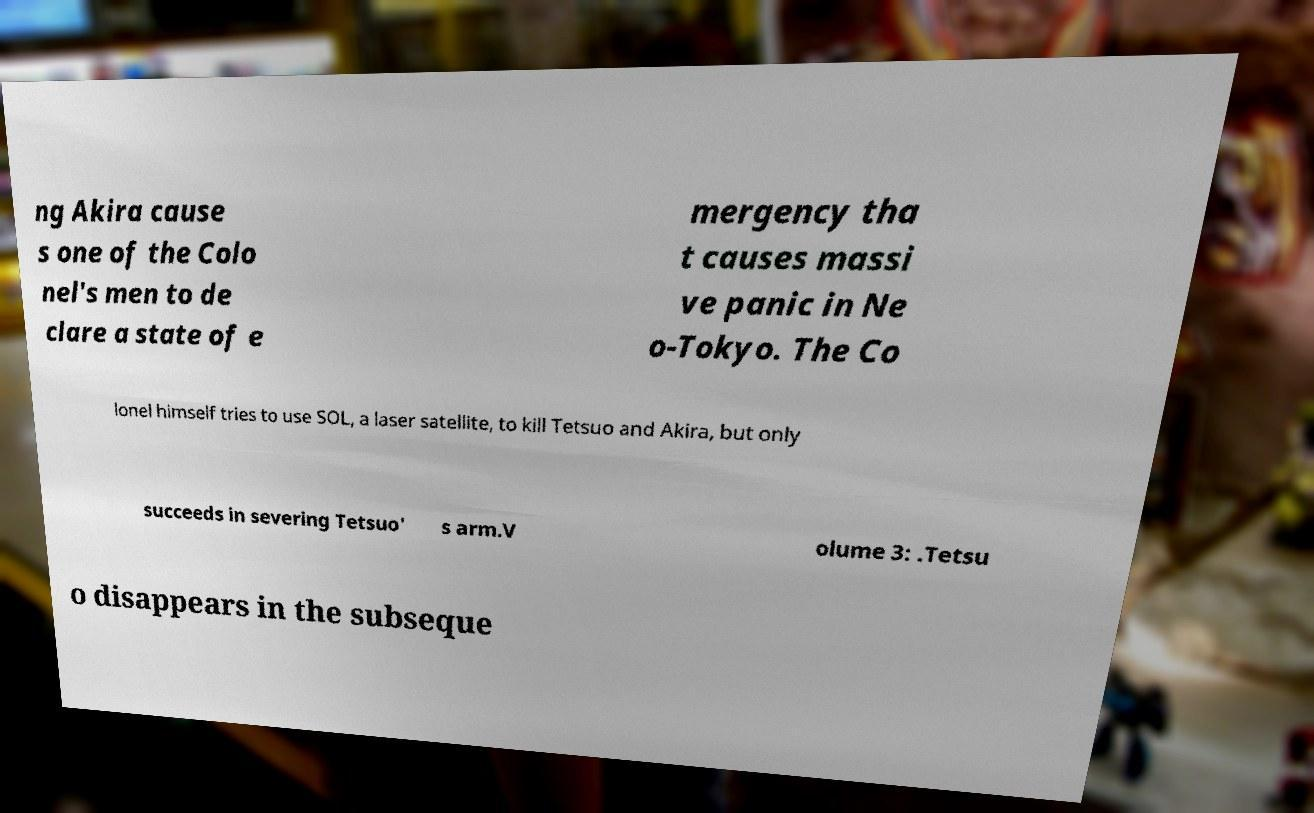I need the written content from this picture converted into text. Can you do that? ng Akira cause s one of the Colo nel's men to de clare a state of e mergency tha t causes massi ve panic in Ne o-Tokyo. The Co lonel himself tries to use SOL, a laser satellite, to kill Tetsuo and Akira, but only succeeds in severing Tetsuo' s arm.V olume 3: .Tetsu o disappears in the subseque 